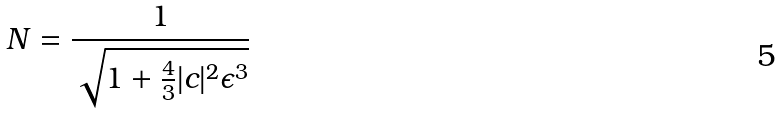<formula> <loc_0><loc_0><loc_500><loc_500>N = { \frac { 1 } { \sqrt { 1 + { \frac { 4 } { 3 } } | c | ^ { 2 } \epsilon ^ { 3 } } } }</formula> 